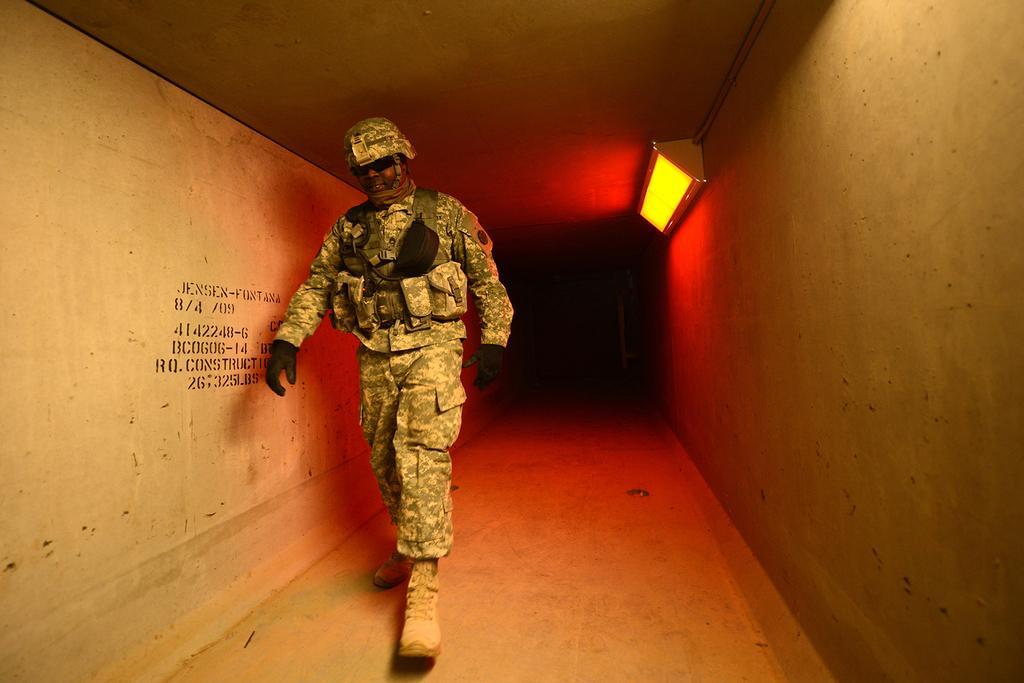How would you summarize this image in a sentence or two? Here in this picture we can see a person walking over a place, as we can see he is wearing a military dress on him and we can see he is wearing gloves, goggles and helmet on him and on the right side we can see a light present over there. 